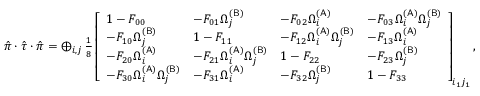<formula> <loc_0><loc_0><loc_500><loc_500>\begin{array} { r } { \hat { \pi } \cdot \hat { \tau } \cdot \hat { \pi } = \bigoplus _ { i , j } \frac { 1 } { 8 } \left [ \begin{array} { l l l l } { 1 - F _ { 0 0 } } & { - F _ { 0 1 } \Omega _ { j } ^ { ( B ) } } & { - F _ { 0 2 } \Omega _ { i } ^ { ( A ) } } & { - F _ { 0 3 } \Omega _ { i } ^ { ( A ) } \Omega _ { j } ^ { ( B ) } } \\ { - F _ { 1 0 } \Omega _ { j } ^ { ( B ) } } & { 1 - F _ { 1 1 } } & { - F _ { 1 2 } \Omega _ { i } ^ { ( A ) } \Omega _ { j } ^ { ( B ) } } & { - F _ { 1 3 } \Omega _ { i } ^ { ( A ) } } \\ { - F _ { 2 0 } \Omega _ { i } ^ { ( A ) } } & { - F _ { 2 1 } \Omega _ { i } ^ { ( A ) } \Omega _ { j } ^ { ( B ) } } & { 1 - F _ { 2 2 } } & { - F _ { 2 3 } \Omega _ { j } ^ { ( B ) } } \\ { - F _ { 3 0 } \Omega _ { i } ^ { ( A ) } \Omega _ { j } ^ { ( B ) } } & { - F _ { 3 1 } \Omega _ { i } ^ { ( A ) } } & { - F _ { 3 2 } \Omega _ { j } ^ { ( B ) } } & { 1 - F _ { 3 3 } } \end{array} \right ] _ { i _ { 1 } j _ { 1 } } , } \end{array}</formula> 